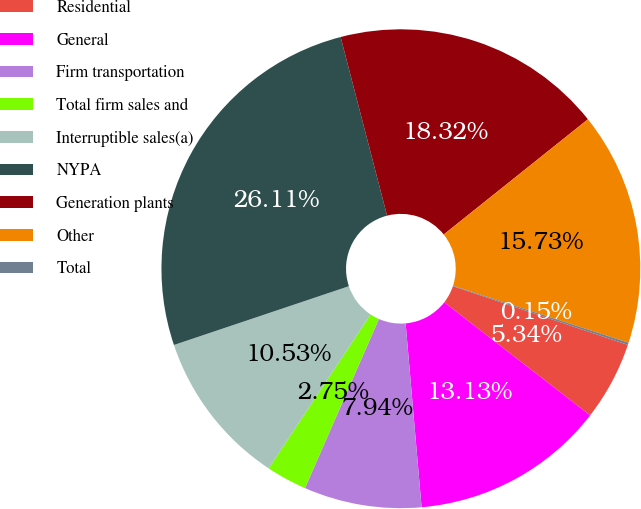<chart> <loc_0><loc_0><loc_500><loc_500><pie_chart><fcel>Residential<fcel>General<fcel>Firm transportation<fcel>Total firm sales and<fcel>Interruptible sales(a)<fcel>NYPA<fcel>Generation plants<fcel>Other<fcel>Total<nl><fcel>5.34%<fcel>13.13%<fcel>7.94%<fcel>2.75%<fcel>10.53%<fcel>26.11%<fcel>18.32%<fcel>15.73%<fcel>0.15%<nl></chart> 